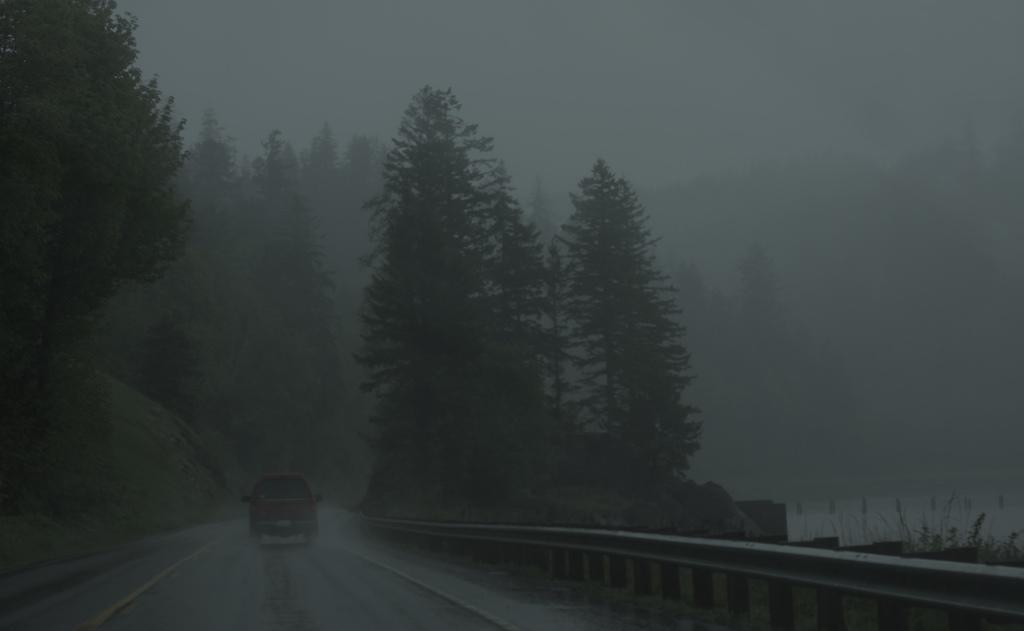What type of vegetation can be seen in the image? There are trees in the image. What mode of transportation is visible on the road? There is a car on the road in the image. What part of the natural environment is visible in the image? The sky is visible in the image. How many stamps are on the trees in the image? There are no stamps present on the trees in the image. What type of flower can be seen growing near the car in the image? There is no flower present near the car in the image. 